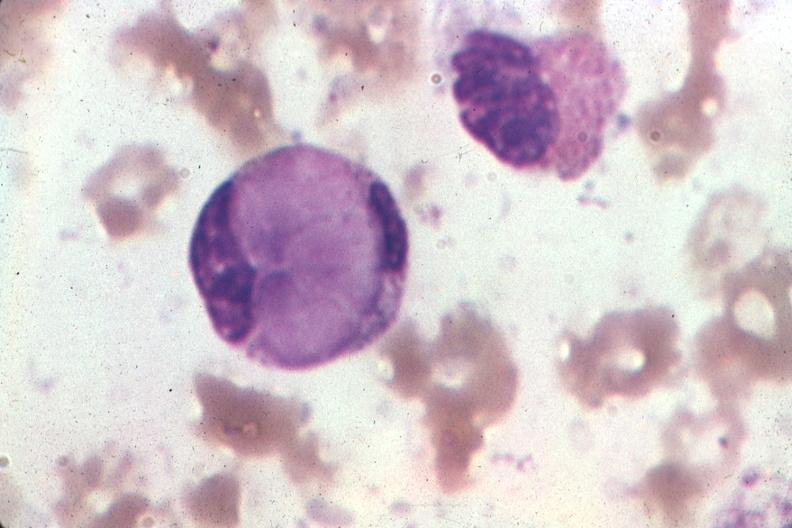what is present?
Answer the question using a single word or phrase. Le cell 